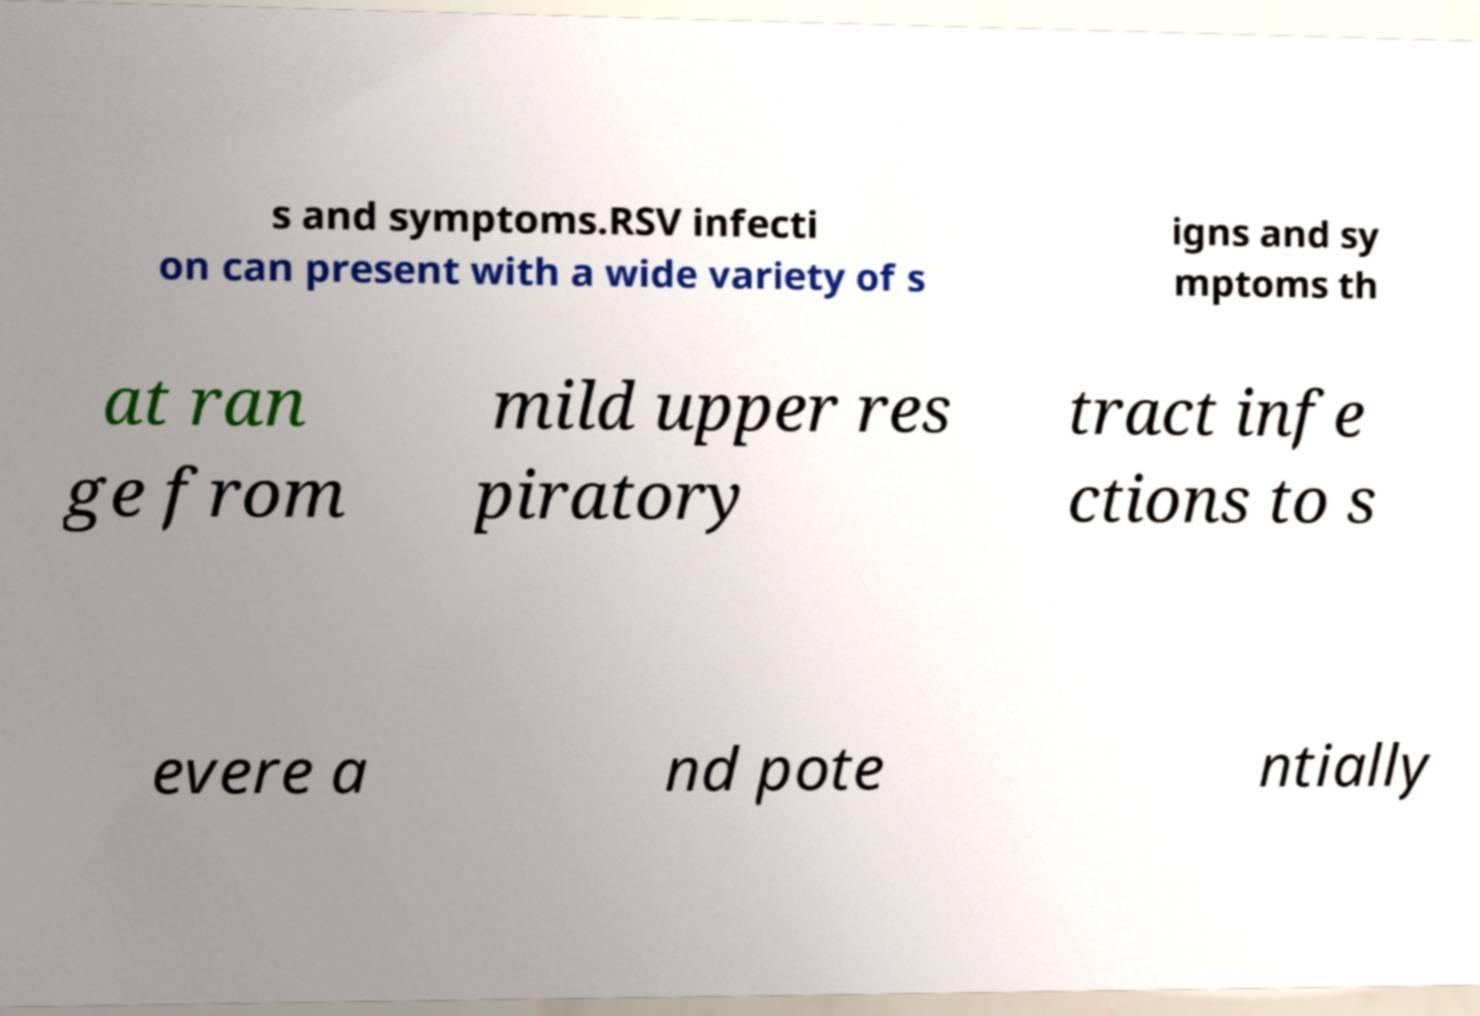What messages or text are displayed in this image? I need them in a readable, typed format. s and symptoms.RSV infecti on can present with a wide variety of s igns and sy mptoms th at ran ge from mild upper res piratory tract infe ctions to s evere a nd pote ntially 